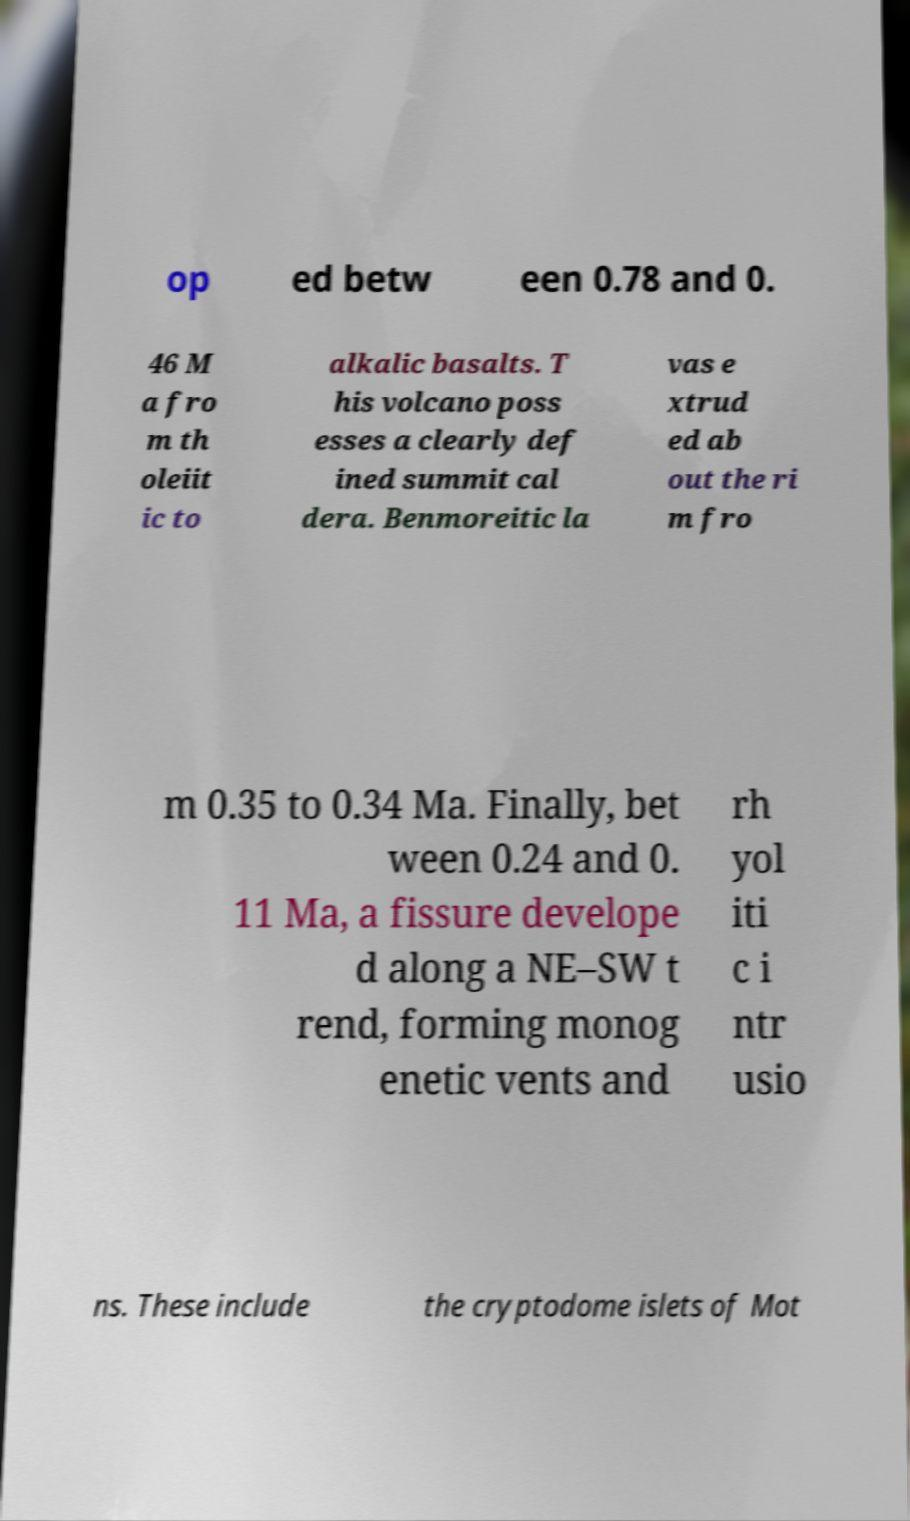Please identify and transcribe the text found in this image. op ed betw een 0.78 and 0. 46 M a fro m th oleiit ic to alkalic basalts. T his volcano poss esses a clearly def ined summit cal dera. Benmoreitic la vas e xtrud ed ab out the ri m fro m 0.35 to 0.34 Ma. Finally, bet ween 0.24 and 0. 11 Ma, a fissure develope d along a NE–SW t rend, forming monog enetic vents and rh yol iti c i ntr usio ns. These include the cryptodome islets of Mot 